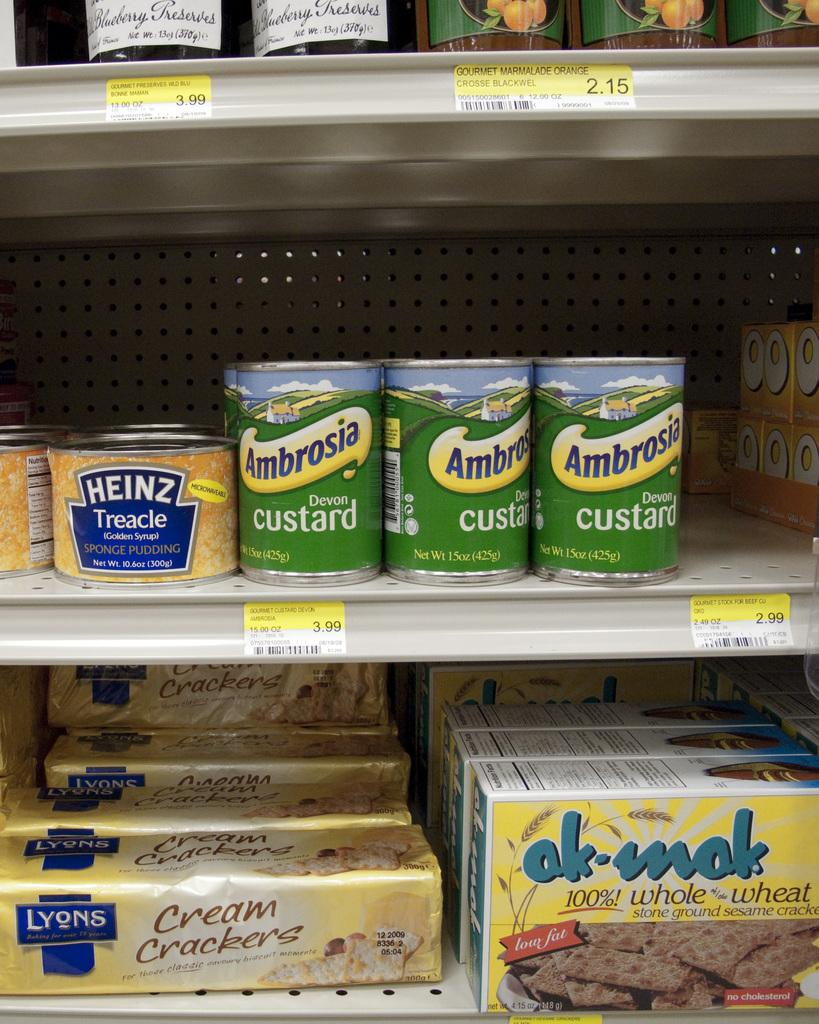What types of items are on the rack in the image? There are bottles, boxes, and food packets on the rack in the image. Can you describe any additional features of the items on the rack? There are stickers present on some of the items. What type of hole can be seen in the image? There is no hole present in the image. What is the belief of the food packets in the image? Food packets do not have beliefs; they are inanimate objects. 